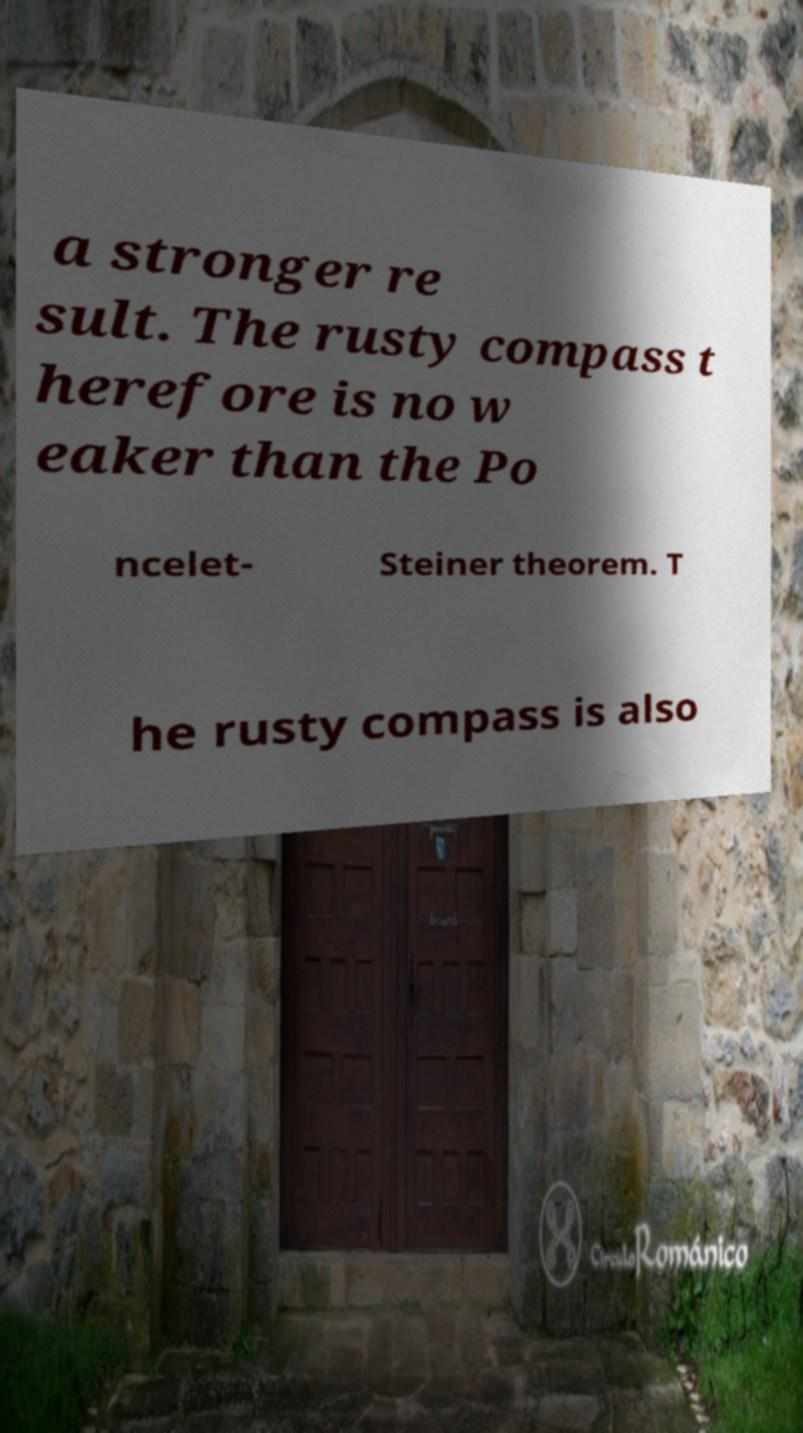Could you assist in decoding the text presented in this image and type it out clearly? a stronger re sult. The rusty compass t herefore is no w eaker than the Po ncelet- Steiner theorem. T he rusty compass is also 